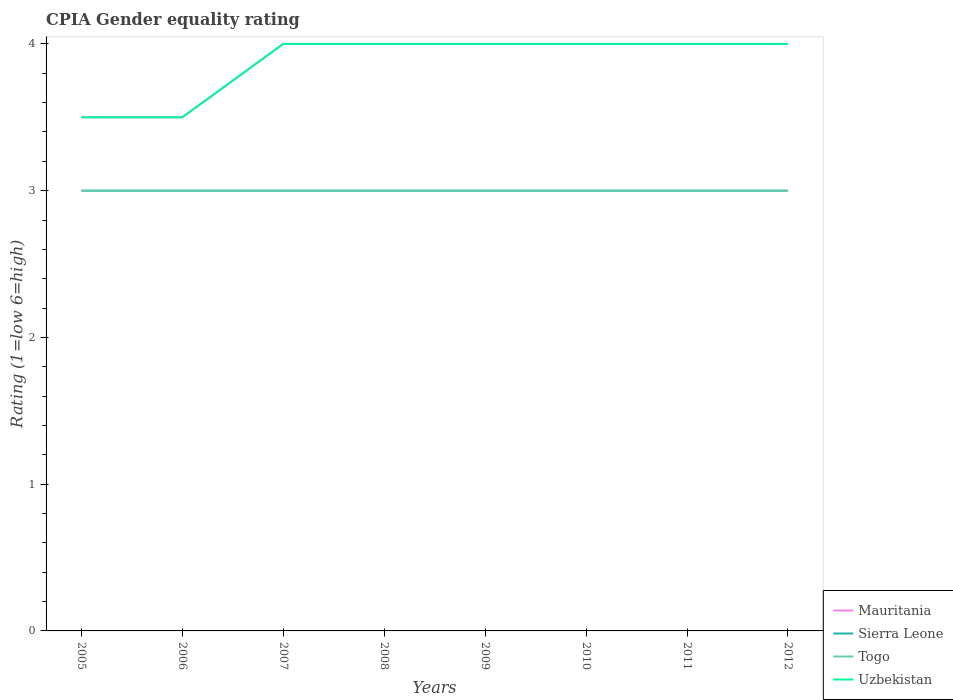How many different coloured lines are there?
Your response must be concise. 4. What is the total CPIA rating in Uzbekistan in the graph?
Provide a short and direct response. 0. How many years are there in the graph?
Offer a very short reply. 8. Are the values on the major ticks of Y-axis written in scientific E-notation?
Make the answer very short. No. Does the graph contain any zero values?
Your answer should be very brief. No. Does the graph contain grids?
Provide a short and direct response. No. Where does the legend appear in the graph?
Your answer should be very brief. Bottom right. How are the legend labels stacked?
Provide a short and direct response. Vertical. What is the title of the graph?
Ensure brevity in your answer.  CPIA Gender equality rating. Does "New Zealand" appear as one of the legend labels in the graph?
Your answer should be compact. No. What is the Rating (1=low 6=high) in Sierra Leone in 2006?
Provide a short and direct response. 3. What is the Rating (1=low 6=high) of Togo in 2006?
Keep it short and to the point. 3. What is the Rating (1=low 6=high) in Mauritania in 2007?
Your answer should be compact. 4. What is the Rating (1=low 6=high) in Sierra Leone in 2007?
Your answer should be compact. 3. What is the Rating (1=low 6=high) in Mauritania in 2008?
Make the answer very short. 4. What is the Rating (1=low 6=high) of Sierra Leone in 2008?
Make the answer very short. 3. What is the Rating (1=low 6=high) of Togo in 2008?
Your answer should be compact. 3. What is the Rating (1=low 6=high) in Mauritania in 2009?
Your answer should be compact. 4. What is the Rating (1=low 6=high) of Uzbekistan in 2009?
Keep it short and to the point. 4. What is the Rating (1=low 6=high) of Mauritania in 2010?
Give a very brief answer. 4. What is the Rating (1=low 6=high) of Sierra Leone in 2010?
Ensure brevity in your answer.  3. What is the Rating (1=low 6=high) of Uzbekistan in 2010?
Your answer should be very brief. 4. What is the Rating (1=low 6=high) of Mauritania in 2011?
Ensure brevity in your answer.  4. What is the Rating (1=low 6=high) in Togo in 2011?
Ensure brevity in your answer.  3. Across all years, what is the maximum Rating (1=low 6=high) of Mauritania?
Your answer should be compact. 4. Across all years, what is the maximum Rating (1=low 6=high) of Sierra Leone?
Provide a succinct answer. 3. Across all years, what is the maximum Rating (1=low 6=high) of Togo?
Make the answer very short. 3. Across all years, what is the maximum Rating (1=low 6=high) of Uzbekistan?
Provide a short and direct response. 4. Across all years, what is the minimum Rating (1=low 6=high) of Mauritania?
Provide a short and direct response. 3.5. Across all years, what is the minimum Rating (1=low 6=high) of Sierra Leone?
Provide a succinct answer. 3. Across all years, what is the minimum Rating (1=low 6=high) in Uzbekistan?
Offer a terse response. 3.5. What is the total Rating (1=low 6=high) of Mauritania in the graph?
Your response must be concise. 31. What is the difference between the Rating (1=low 6=high) in Mauritania in 2005 and that in 2006?
Your response must be concise. 0. What is the difference between the Rating (1=low 6=high) in Sierra Leone in 2005 and that in 2006?
Offer a terse response. 0. What is the difference between the Rating (1=low 6=high) of Uzbekistan in 2005 and that in 2006?
Offer a very short reply. 0. What is the difference between the Rating (1=low 6=high) of Sierra Leone in 2005 and that in 2007?
Provide a succinct answer. 0. What is the difference between the Rating (1=low 6=high) of Togo in 2005 and that in 2007?
Offer a very short reply. 0. What is the difference between the Rating (1=low 6=high) in Mauritania in 2005 and that in 2008?
Give a very brief answer. -0.5. What is the difference between the Rating (1=low 6=high) of Togo in 2005 and that in 2008?
Offer a very short reply. 0. What is the difference between the Rating (1=low 6=high) of Sierra Leone in 2005 and that in 2009?
Make the answer very short. 0. What is the difference between the Rating (1=low 6=high) in Sierra Leone in 2005 and that in 2010?
Provide a succinct answer. 0. What is the difference between the Rating (1=low 6=high) in Togo in 2005 and that in 2010?
Your response must be concise. 0. What is the difference between the Rating (1=low 6=high) in Sierra Leone in 2005 and that in 2011?
Give a very brief answer. 0. What is the difference between the Rating (1=low 6=high) of Togo in 2005 and that in 2011?
Provide a short and direct response. 0. What is the difference between the Rating (1=low 6=high) of Mauritania in 2005 and that in 2012?
Your response must be concise. -0.5. What is the difference between the Rating (1=low 6=high) in Sierra Leone in 2005 and that in 2012?
Give a very brief answer. 0. What is the difference between the Rating (1=low 6=high) in Uzbekistan in 2005 and that in 2012?
Your response must be concise. -0.5. What is the difference between the Rating (1=low 6=high) in Mauritania in 2006 and that in 2008?
Provide a short and direct response. -0.5. What is the difference between the Rating (1=low 6=high) of Togo in 2006 and that in 2008?
Offer a very short reply. 0. What is the difference between the Rating (1=low 6=high) of Uzbekistan in 2006 and that in 2008?
Your answer should be very brief. -0.5. What is the difference between the Rating (1=low 6=high) of Togo in 2006 and that in 2009?
Offer a terse response. 0. What is the difference between the Rating (1=low 6=high) in Togo in 2006 and that in 2010?
Offer a terse response. 0. What is the difference between the Rating (1=low 6=high) of Mauritania in 2006 and that in 2011?
Your answer should be very brief. -0.5. What is the difference between the Rating (1=low 6=high) in Sierra Leone in 2006 and that in 2011?
Offer a terse response. 0. What is the difference between the Rating (1=low 6=high) of Togo in 2006 and that in 2011?
Ensure brevity in your answer.  0. What is the difference between the Rating (1=low 6=high) of Uzbekistan in 2006 and that in 2011?
Your response must be concise. -0.5. What is the difference between the Rating (1=low 6=high) in Mauritania in 2006 and that in 2012?
Ensure brevity in your answer.  -0.5. What is the difference between the Rating (1=low 6=high) in Togo in 2006 and that in 2012?
Your answer should be compact. 0. What is the difference between the Rating (1=low 6=high) in Sierra Leone in 2007 and that in 2008?
Your response must be concise. 0. What is the difference between the Rating (1=low 6=high) of Mauritania in 2007 and that in 2009?
Make the answer very short. 0. What is the difference between the Rating (1=low 6=high) of Uzbekistan in 2007 and that in 2009?
Your response must be concise. 0. What is the difference between the Rating (1=low 6=high) of Sierra Leone in 2007 and that in 2010?
Your response must be concise. 0. What is the difference between the Rating (1=low 6=high) in Uzbekistan in 2007 and that in 2010?
Provide a succinct answer. 0. What is the difference between the Rating (1=low 6=high) in Sierra Leone in 2007 and that in 2011?
Provide a short and direct response. 0. What is the difference between the Rating (1=low 6=high) in Togo in 2007 and that in 2011?
Your answer should be compact. 0. What is the difference between the Rating (1=low 6=high) in Uzbekistan in 2007 and that in 2011?
Provide a succinct answer. 0. What is the difference between the Rating (1=low 6=high) of Sierra Leone in 2007 and that in 2012?
Offer a very short reply. 0. What is the difference between the Rating (1=low 6=high) in Togo in 2007 and that in 2012?
Your answer should be very brief. 0. What is the difference between the Rating (1=low 6=high) in Uzbekistan in 2007 and that in 2012?
Give a very brief answer. 0. What is the difference between the Rating (1=low 6=high) of Sierra Leone in 2008 and that in 2009?
Provide a short and direct response. 0. What is the difference between the Rating (1=low 6=high) in Uzbekistan in 2008 and that in 2009?
Provide a succinct answer. 0. What is the difference between the Rating (1=low 6=high) of Togo in 2008 and that in 2010?
Provide a succinct answer. 0. What is the difference between the Rating (1=low 6=high) of Uzbekistan in 2008 and that in 2010?
Provide a succinct answer. 0. What is the difference between the Rating (1=low 6=high) in Sierra Leone in 2008 and that in 2011?
Offer a terse response. 0. What is the difference between the Rating (1=low 6=high) in Mauritania in 2008 and that in 2012?
Your answer should be very brief. 0. What is the difference between the Rating (1=low 6=high) of Mauritania in 2009 and that in 2010?
Ensure brevity in your answer.  0. What is the difference between the Rating (1=low 6=high) of Uzbekistan in 2009 and that in 2010?
Provide a succinct answer. 0. What is the difference between the Rating (1=low 6=high) in Mauritania in 2009 and that in 2011?
Offer a very short reply. 0. What is the difference between the Rating (1=low 6=high) of Sierra Leone in 2010 and that in 2011?
Ensure brevity in your answer.  0. What is the difference between the Rating (1=low 6=high) in Togo in 2010 and that in 2012?
Your response must be concise. 0. What is the difference between the Rating (1=low 6=high) in Uzbekistan in 2010 and that in 2012?
Give a very brief answer. 0. What is the difference between the Rating (1=low 6=high) of Sierra Leone in 2011 and that in 2012?
Ensure brevity in your answer.  0. What is the difference between the Rating (1=low 6=high) in Sierra Leone in 2005 and the Rating (1=low 6=high) in Togo in 2006?
Your answer should be very brief. 0. What is the difference between the Rating (1=low 6=high) of Togo in 2005 and the Rating (1=low 6=high) of Uzbekistan in 2006?
Keep it short and to the point. -0.5. What is the difference between the Rating (1=low 6=high) in Mauritania in 2005 and the Rating (1=low 6=high) in Sierra Leone in 2007?
Ensure brevity in your answer.  0.5. What is the difference between the Rating (1=low 6=high) in Mauritania in 2005 and the Rating (1=low 6=high) in Togo in 2007?
Your answer should be compact. 0.5. What is the difference between the Rating (1=low 6=high) of Togo in 2005 and the Rating (1=low 6=high) of Uzbekistan in 2007?
Ensure brevity in your answer.  -1. What is the difference between the Rating (1=low 6=high) in Mauritania in 2005 and the Rating (1=low 6=high) in Uzbekistan in 2008?
Make the answer very short. -0.5. What is the difference between the Rating (1=low 6=high) of Sierra Leone in 2005 and the Rating (1=low 6=high) of Togo in 2008?
Your response must be concise. 0. What is the difference between the Rating (1=low 6=high) of Sierra Leone in 2005 and the Rating (1=low 6=high) of Uzbekistan in 2008?
Offer a very short reply. -1. What is the difference between the Rating (1=low 6=high) of Togo in 2005 and the Rating (1=low 6=high) of Uzbekistan in 2008?
Keep it short and to the point. -1. What is the difference between the Rating (1=low 6=high) of Mauritania in 2005 and the Rating (1=low 6=high) of Togo in 2009?
Your answer should be very brief. 0.5. What is the difference between the Rating (1=low 6=high) of Sierra Leone in 2005 and the Rating (1=low 6=high) of Uzbekistan in 2009?
Your answer should be very brief. -1. What is the difference between the Rating (1=low 6=high) in Mauritania in 2005 and the Rating (1=low 6=high) in Sierra Leone in 2010?
Offer a very short reply. 0.5. What is the difference between the Rating (1=low 6=high) of Mauritania in 2005 and the Rating (1=low 6=high) of Togo in 2010?
Your response must be concise. 0.5. What is the difference between the Rating (1=low 6=high) of Mauritania in 2005 and the Rating (1=low 6=high) of Uzbekistan in 2010?
Your response must be concise. -0.5. What is the difference between the Rating (1=low 6=high) in Sierra Leone in 2005 and the Rating (1=low 6=high) in Togo in 2010?
Offer a very short reply. 0. What is the difference between the Rating (1=low 6=high) of Sierra Leone in 2005 and the Rating (1=low 6=high) of Uzbekistan in 2010?
Your answer should be compact. -1. What is the difference between the Rating (1=low 6=high) in Togo in 2005 and the Rating (1=low 6=high) in Uzbekistan in 2010?
Make the answer very short. -1. What is the difference between the Rating (1=low 6=high) in Mauritania in 2005 and the Rating (1=low 6=high) in Sierra Leone in 2011?
Offer a very short reply. 0.5. What is the difference between the Rating (1=low 6=high) in Sierra Leone in 2005 and the Rating (1=low 6=high) in Togo in 2011?
Your answer should be very brief. 0. What is the difference between the Rating (1=low 6=high) in Mauritania in 2005 and the Rating (1=low 6=high) in Togo in 2012?
Provide a succinct answer. 0.5. What is the difference between the Rating (1=low 6=high) of Mauritania in 2005 and the Rating (1=low 6=high) of Uzbekistan in 2012?
Offer a terse response. -0.5. What is the difference between the Rating (1=low 6=high) in Sierra Leone in 2005 and the Rating (1=low 6=high) in Togo in 2012?
Provide a succinct answer. 0. What is the difference between the Rating (1=low 6=high) of Sierra Leone in 2005 and the Rating (1=low 6=high) of Uzbekistan in 2012?
Offer a terse response. -1. What is the difference between the Rating (1=low 6=high) of Sierra Leone in 2006 and the Rating (1=low 6=high) of Uzbekistan in 2007?
Your answer should be compact. -1. What is the difference between the Rating (1=low 6=high) of Mauritania in 2006 and the Rating (1=low 6=high) of Sierra Leone in 2008?
Your response must be concise. 0.5. What is the difference between the Rating (1=low 6=high) of Mauritania in 2006 and the Rating (1=low 6=high) of Togo in 2008?
Your answer should be very brief. 0.5. What is the difference between the Rating (1=low 6=high) in Sierra Leone in 2006 and the Rating (1=low 6=high) in Togo in 2008?
Your answer should be very brief. 0. What is the difference between the Rating (1=low 6=high) in Mauritania in 2006 and the Rating (1=low 6=high) in Uzbekistan in 2009?
Offer a terse response. -0.5. What is the difference between the Rating (1=low 6=high) of Sierra Leone in 2006 and the Rating (1=low 6=high) of Uzbekistan in 2009?
Keep it short and to the point. -1. What is the difference between the Rating (1=low 6=high) of Togo in 2006 and the Rating (1=low 6=high) of Uzbekistan in 2009?
Give a very brief answer. -1. What is the difference between the Rating (1=low 6=high) in Mauritania in 2006 and the Rating (1=low 6=high) in Sierra Leone in 2010?
Give a very brief answer. 0.5. What is the difference between the Rating (1=low 6=high) in Mauritania in 2006 and the Rating (1=low 6=high) in Uzbekistan in 2010?
Your response must be concise. -0.5. What is the difference between the Rating (1=low 6=high) in Sierra Leone in 2006 and the Rating (1=low 6=high) in Togo in 2010?
Give a very brief answer. 0. What is the difference between the Rating (1=low 6=high) of Mauritania in 2006 and the Rating (1=low 6=high) of Sierra Leone in 2011?
Ensure brevity in your answer.  0.5. What is the difference between the Rating (1=low 6=high) in Mauritania in 2006 and the Rating (1=low 6=high) in Uzbekistan in 2011?
Provide a short and direct response. -0.5. What is the difference between the Rating (1=low 6=high) in Sierra Leone in 2006 and the Rating (1=low 6=high) in Uzbekistan in 2011?
Your answer should be compact. -1. What is the difference between the Rating (1=low 6=high) of Mauritania in 2006 and the Rating (1=low 6=high) of Togo in 2012?
Keep it short and to the point. 0.5. What is the difference between the Rating (1=low 6=high) of Mauritania in 2007 and the Rating (1=low 6=high) of Uzbekistan in 2008?
Make the answer very short. 0. What is the difference between the Rating (1=low 6=high) in Sierra Leone in 2007 and the Rating (1=low 6=high) in Togo in 2008?
Provide a short and direct response. 0. What is the difference between the Rating (1=low 6=high) in Togo in 2007 and the Rating (1=low 6=high) in Uzbekistan in 2008?
Give a very brief answer. -1. What is the difference between the Rating (1=low 6=high) in Mauritania in 2007 and the Rating (1=low 6=high) in Uzbekistan in 2009?
Your answer should be very brief. 0. What is the difference between the Rating (1=low 6=high) of Mauritania in 2007 and the Rating (1=low 6=high) of Sierra Leone in 2010?
Offer a terse response. 1. What is the difference between the Rating (1=low 6=high) of Sierra Leone in 2007 and the Rating (1=low 6=high) of Uzbekistan in 2010?
Your answer should be very brief. -1. What is the difference between the Rating (1=low 6=high) of Togo in 2007 and the Rating (1=low 6=high) of Uzbekistan in 2010?
Give a very brief answer. -1. What is the difference between the Rating (1=low 6=high) of Mauritania in 2007 and the Rating (1=low 6=high) of Sierra Leone in 2011?
Provide a short and direct response. 1. What is the difference between the Rating (1=low 6=high) in Mauritania in 2007 and the Rating (1=low 6=high) in Togo in 2011?
Your answer should be compact. 1. What is the difference between the Rating (1=low 6=high) in Mauritania in 2007 and the Rating (1=low 6=high) in Sierra Leone in 2012?
Ensure brevity in your answer.  1. What is the difference between the Rating (1=low 6=high) in Mauritania in 2007 and the Rating (1=low 6=high) in Togo in 2012?
Ensure brevity in your answer.  1. What is the difference between the Rating (1=low 6=high) in Mauritania in 2007 and the Rating (1=low 6=high) in Uzbekistan in 2012?
Provide a succinct answer. 0. What is the difference between the Rating (1=low 6=high) in Sierra Leone in 2007 and the Rating (1=low 6=high) in Togo in 2012?
Your answer should be compact. 0. What is the difference between the Rating (1=low 6=high) in Sierra Leone in 2007 and the Rating (1=low 6=high) in Uzbekistan in 2012?
Provide a short and direct response. -1. What is the difference between the Rating (1=low 6=high) of Mauritania in 2008 and the Rating (1=low 6=high) of Sierra Leone in 2009?
Keep it short and to the point. 1. What is the difference between the Rating (1=low 6=high) of Mauritania in 2008 and the Rating (1=low 6=high) of Togo in 2009?
Offer a very short reply. 1. What is the difference between the Rating (1=low 6=high) in Sierra Leone in 2008 and the Rating (1=low 6=high) in Uzbekistan in 2009?
Offer a terse response. -1. What is the difference between the Rating (1=low 6=high) in Mauritania in 2008 and the Rating (1=low 6=high) in Uzbekistan in 2010?
Provide a short and direct response. 0. What is the difference between the Rating (1=low 6=high) in Sierra Leone in 2008 and the Rating (1=low 6=high) in Togo in 2010?
Your answer should be very brief. 0. What is the difference between the Rating (1=low 6=high) in Mauritania in 2008 and the Rating (1=low 6=high) in Sierra Leone in 2011?
Your answer should be very brief. 1. What is the difference between the Rating (1=low 6=high) in Mauritania in 2008 and the Rating (1=low 6=high) in Uzbekistan in 2011?
Provide a succinct answer. 0. What is the difference between the Rating (1=low 6=high) of Togo in 2008 and the Rating (1=low 6=high) of Uzbekistan in 2011?
Keep it short and to the point. -1. What is the difference between the Rating (1=low 6=high) of Sierra Leone in 2008 and the Rating (1=low 6=high) of Togo in 2012?
Your answer should be very brief. 0. What is the difference between the Rating (1=low 6=high) in Sierra Leone in 2008 and the Rating (1=low 6=high) in Uzbekistan in 2012?
Provide a short and direct response. -1. What is the difference between the Rating (1=low 6=high) of Togo in 2008 and the Rating (1=low 6=high) of Uzbekistan in 2012?
Your answer should be very brief. -1. What is the difference between the Rating (1=low 6=high) of Mauritania in 2009 and the Rating (1=low 6=high) of Togo in 2010?
Offer a very short reply. 1. What is the difference between the Rating (1=low 6=high) of Sierra Leone in 2009 and the Rating (1=low 6=high) of Togo in 2010?
Give a very brief answer. 0. What is the difference between the Rating (1=low 6=high) in Sierra Leone in 2009 and the Rating (1=low 6=high) in Uzbekistan in 2010?
Your answer should be very brief. -1. What is the difference between the Rating (1=low 6=high) of Mauritania in 2009 and the Rating (1=low 6=high) of Sierra Leone in 2011?
Offer a terse response. 1. What is the difference between the Rating (1=low 6=high) in Mauritania in 2009 and the Rating (1=low 6=high) in Togo in 2011?
Provide a short and direct response. 1. What is the difference between the Rating (1=low 6=high) in Mauritania in 2009 and the Rating (1=low 6=high) in Uzbekistan in 2011?
Make the answer very short. 0. What is the difference between the Rating (1=low 6=high) in Sierra Leone in 2009 and the Rating (1=low 6=high) in Uzbekistan in 2011?
Provide a short and direct response. -1. What is the difference between the Rating (1=low 6=high) of Mauritania in 2009 and the Rating (1=low 6=high) of Togo in 2012?
Provide a succinct answer. 1. What is the difference between the Rating (1=low 6=high) of Sierra Leone in 2009 and the Rating (1=low 6=high) of Togo in 2012?
Your response must be concise. 0. What is the difference between the Rating (1=low 6=high) of Sierra Leone in 2009 and the Rating (1=low 6=high) of Uzbekistan in 2012?
Offer a terse response. -1. What is the difference between the Rating (1=low 6=high) in Togo in 2009 and the Rating (1=low 6=high) in Uzbekistan in 2012?
Keep it short and to the point. -1. What is the difference between the Rating (1=low 6=high) of Mauritania in 2010 and the Rating (1=low 6=high) of Uzbekistan in 2011?
Provide a short and direct response. 0. What is the difference between the Rating (1=low 6=high) in Sierra Leone in 2010 and the Rating (1=low 6=high) in Uzbekistan in 2011?
Keep it short and to the point. -1. What is the difference between the Rating (1=low 6=high) of Mauritania in 2010 and the Rating (1=low 6=high) of Sierra Leone in 2012?
Provide a succinct answer. 1. What is the difference between the Rating (1=low 6=high) in Mauritania in 2010 and the Rating (1=low 6=high) in Uzbekistan in 2012?
Ensure brevity in your answer.  0. What is the difference between the Rating (1=low 6=high) of Sierra Leone in 2010 and the Rating (1=low 6=high) of Togo in 2012?
Offer a very short reply. 0. What is the difference between the Rating (1=low 6=high) of Sierra Leone in 2010 and the Rating (1=low 6=high) of Uzbekistan in 2012?
Provide a short and direct response. -1. What is the difference between the Rating (1=low 6=high) in Togo in 2010 and the Rating (1=low 6=high) in Uzbekistan in 2012?
Keep it short and to the point. -1. What is the difference between the Rating (1=low 6=high) in Mauritania in 2011 and the Rating (1=low 6=high) in Sierra Leone in 2012?
Ensure brevity in your answer.  1. What is the difference between the Rating (1=low 6=high) of Mauritania in 2011 and the Rating (1=low 6=high) of Togo in 2012?
Your answer should be very brief. 1. What is the difference between the Rating (1=low 6=high) of Mauritania in 2011 and the Rating (1=low 6=high) of Uzbekistan in 2012?
Offer a very short reply. 0. What is the difference between the Rating (1=low 6=high) of Sierra Leone in 2011 and the Rating (1=low 6=high) of Togo in 2012?
Your answer should be very brief. 0. What is the average Rating (1=low 6=high) of Mauritania per year?
Offer a terse response. 3.88. What is the average Rating (1=low 6=high) in Sierra Leone per year?
Ensure brevity in your answer.  3. What is the average Rating (1=low 6=high) of Togo per year?
Your response must be concise. 3. What is the average Rating (1=low 6=high) in Uzbekistan per year?
Keep it short and to the point. 3.88. In the year 2005, what is the difference between the Rating (1=low 6=high) in Sierra Leone and Rating (1=low 6=high) in Togo?
Keep it short and to the point. 0. In the year 2005, what is the difference between the Rating (1=low 6=high) of Sierra Leone and Rating (1=low 6=high) of Uzbekistan?
Provide a succinct answer. -0.5. In the year 2006, what is the difference between the Rating (1=low 6=high) in Mauritania and Rating (1=low 6=high) in Uzbekistan?
Ensure brevity in your answer.  0. In the year 2006, what is the difference between the Rating (1=low 6=high) of Togo and Rating (1=low 6=high) of Uzbekistan?
Your response must be concise. -0.5. In the year 2007, what is the difference between the Rating (1=low 6=high) of Mauritania and Rating (1=low 6=high) of Togo?
Your answer should be very brief. 1. In the year 2007, what is the difference between the Rating (1=low 6=high) of Togo and Rating (1=low 6=high) of Uzbekistan?
Ensure brevity in your answer.  -1. In the year 2008, what is the difference between the Rating (1=low 6=high) in Mauritania and Rating (1=low 6=high) in Sierra Leone?
Ensure brevity in your answer.  1. In the year 2008, what is the difference between the Rating (1=low 6=high) of Mauritania and Rating (1=low 6=high) of Togo?
Make the answer very short. 1. In the year 2008, what is the difference between the Rating (1=low 6=high) in Mauritania and Rating (1=low 6=high) in Uzbekistan?
Make the answer very short. 0. In the year 2008, what is the difference between the Rating (1=low 6=high) of Sierra Leone and Rating (1=low 6=high) of Togo?
Provide a short and direct response. 0. In the year 2008, what is the difference between the Rating (1=low 6=high) of Sierra Leone and Rating (1=low 6=high) of Uzbekistan?
Provide a succinct answer. -1. In the year 2008, what is the difference between the Rating (1=low 6=high) of Togo and Rating (1=low 6=high) of Uzbekistan?
Offer a very short reply. -1. In the year 2009, what is the difference between the Rating (1=low 6=high) of Mauritania and Rating (1=low 6=high) of Uzbekistan?
Keep it short and to the point. 0. In the year 2010, what is the difference between the Rating (1=low 6=high) in Mauritania and Rating (1=low 6=high) in Sierra Leone?
Keep it short and to the point. 1. In the year 2010, what is the difference between the Rating (1=low 6=high) in Mauritania and Rating (1=low 6=high) in Togo?
Make the answer very short. 1. In the year 2010, what is the difference between the Rating (1=low 6=high) in Sierra Leone and Rating (1=low 6=high) in Uzbekistan?
Your response must be concise. -1. In the year 2011, what is the difference between the Rating (1=low 6=high) in Mauritania and Rating (1=low 6=high) in Sierra Leone?
Ensure brevity in your answer.  1. In the year 2011, what is the difference between the Rating (1=low 6=high) in Sierra Leone and Rating (1=low 6=high) in Togo?
Give a very brief answer. 0. In the year 2011, what is the difference between the Rating (1=low 6=high) of Sierra Leone and Rating (1=low 6=high) of Uzbekistan?
Provide a short and direct response. -1. In the year 2011, what is the difference between the Rating (1=low 6=high) in Togo and Rating (1=low 6=high) in Uzbekistan?
Ensure brevity in your answer.  -1. In the year 2012, what is the difference between the Rating (1=low 6=high) in Mauritania and Rating (1=low 6=high) in Togo?
Give a very brief answer. 1. In the year 2012, what is the difference between the Rating (1=low 6=high) of Mauritania and Rating (1=low 6=high) of Uzbekistan?
Your answer should be very brief. 0. In the year 2012, what is the difference between the Rating (1=low 6=high) in Sierra Leone and Rating (1=low 6=high) in Uzbekistan?
Provide a succinct answer. -1. In the year 2012, what is the difference between the Rating (1=low 6=high) of Togo and Rating (1=low 6=high) of Uzbekistan?
Ensure brevity in your answer.  -1. What is the ratio of the Rating (1=low 6=high) in Uzbekistan in 2005 to that in 2006?
Provide a short and direct response. 1. What is the ratio of the Rating (1=low 6=high) of Mauritania in 2005 to that in 2007?
Give a very brief answer. 0.88. What is the ratio of the Rating (1=low 6=high) in Mauritania in 2005 to that in 2008?
Provide a short and direct response. 0.88. What is the ratio of the Rating (1=low 6=high) of Mauritania in 2005 to that in 2009?
Keep it short and to the point. 0.88. What is the ratio of the Rating (1=low 6=high) of Uzbekistan in 2005 to that in 2009?
Your answer should be very brief. 0.88. What is the ratio of the Rating (1=low 6=high) of Mauritania in 2005 to that in 2010?
Your answer should be very brief. 0.88. What is the ratio of the Rating (1=low 6=high) of Sierra Leone in 2005 to that in 2010?
Your response must be concise. 1. What is the ratio of the Rating (1=low 6=high) of Uzbekistan in 2005 to that in 2010?
Make the answer very short. 0.88. What is the ratio of the Rating (1=low 6=high) in Mauritania in 2005 to that in 2011?
Make the answer very short. 0.88. What is the ratio of the Rating (1=low 6=high) of Uzbekistan in 2005 to that in 2011?
Your response must be concise. 0.88. What is the ratio of the Rating (1=low 6=high) in Mauritania in 2005 to that in 2012?
Offer a terse response. 0.88. What is the ratio of the Rating (1=low 6=high) in Sierra Leone in 2005 to that in 2012?
Provide a short and direct response. 1. What is the ratio of the Rating (1=low 6=high) of Uzbekistan in 2005 to that in 2012?
Provide a short and direct response. 0.88. What is the ratio of the Rating (1=low 6=high) in Sierra Leone in 2006 to that in 2007?
Your answer should be very brief. 1. What is the ratio of the Rating (1=low 6=high) of Togo in 2006 to that in 2008?
Provide a short and direct response. 1. What is the ratio of the Rating (1=low 6=high) in Mauritania in 2006 to that in 2009?
Ensure brevity in your answer.  0.88. What is the ratio of the Rating (1=low 6=high) in Uzbekistan in 2006 to that in 2009?
Provide a short and direct response. 0.88. What is the ratio of the Rating (1=low 6=high) in Sierra Leone in 2006 to that in 2010?
Ensure brevity in your answer.  1. What is the ratio of the Rating (1=low 6=high) of Mauritania in 2006 to that in 2011?
Your response must be concise. 0.88. What is the ratio of the Rating (1=low 6=high) in Sierra Leone in 2006 to that in 2011?
Make the answer very short. 1. What is the ratio of the Rating (1=low 6=high) in Mauritania in 2007 to that in 2008?
Provide a succinct answer. 1. What is the ratio of the Rating (1=low 6=high) in Sierra Leone in 2007 to that in 2008?
Ensure brevity in your answer.  1. What is the ratio of the Rating (1=low 6=high) of Uzbekistan in 2007 to that in 2008?
Give a very brief answer. 1. What is the ratio of the Rating (1=low 6=high) of Mauritania in 2007 to that in 2009?
Your response must be concise. 1. What is the ratio of the Rating (1=low 6=high) in Togo in 2007 to that in 2009?
Your answer should be very brief. 1. What is the ratio of the Rating (1=low 6=high) of Uzbekistan in 2007 to that in 2009?
Your answer should be very brief. 1. What is the ratio of the Rating (1=low 6=high) of Sierra Leone in 2007 to that in 2010?
Provide a short and direct response. 1. What is the ratio of the Rating (1=low 6=high) of Togo in 2007 to that in 2010?
Provide a succinct answer. 1. What is the ratio of the Rating (1=low 6=high) in Uzbekistan in 2007 to that in 2011?
Give a very brief answer. 1. What is the ratio of the Rating (1=low 6=high) of Togo in 2007 to that in 2012?
Ensure brevity in your answer.  1. What is the ratio of the Rating (1=low 6=high) in Uzbekistan in 2007 to that in 2012?
Provide a short and direct response. 1. What is the ratio of the Rating (1=low 6=high) of Sierra Leone in 2008 to that in 2009?
Your answer should be compact. 1. What is the ratio of the Rating (1=low 6=high) of Togo in 2008 to that in 2009?
Offer a very short reply. 1. What is the ratio of the Rating (1=low 6=high) of Togo in 2008 to that in 2010?
Provide a short and direct response. 1. What is the ratio of the Rating (1=low 6=high) in Togo in 2008 to that in 2011?
Make the answer very short. 1. What is the ratio of the Rating (1=low 6=high) in Sierra Leone in 2008 to that in 2012?
Offer a very short reply. 1. What is the ratio of the Rating (1=low 6=high) of Togo in 2008 to that in 2012?
Provide a succinct answer. 1. What is the ratio of the Rating (1=low 6=high) of Uzbekistan in 2008 to that in 2012?
Your response must be concise. 1. What is the ratio of the Rating (1=low 6=high) of Mauritania in 2009 to that in 2010?
Keep it short and to the point. 1. What is the ratio of the Rating (1=low 6=high) of Sierra Leone in 2009 to that in 2010?
Your answer should be very brief. 1. What is the ratio of the Rating (1=low 6=high) in Togo in 2009 to that in 2010?
Offer a terse response. 1. What is the ratio of the Rating (1=low 6=high) in Mauritania in 2009 to that in 2011?
Provide a short and direct response. 1. What is the ratio of the Rating (1=low 6=high) of Sierra Leone in 2009 to that in 2011?
Provide a succinct answer. 1. What is the ratio of the Rating (1=low 6=high) in Mauritania in 2009 to that in 2012?
Keep it short and to the point. 1. What is the ratio of the Rating (1=low 6=high) of Sierra Leone in 2009 to that in 2012?
Your answer should be very brief. 1. What is the ratio of the Rating (1=low 6=high) in Togo in 2009 to that in 2012?
Offer a very short reply. 1. What is the ratio of the Rating (1=low 6=high) in Uzbekistan in 2009 to that in 2012?
Keep it short and to the point. 1. What is the ratio of the Rating (1=low 6=high) of Uzbekistan in 2010 to that in 2011?
Offer a terse response. 1. What is the ratio of the Rating (1=low 6=high) in Mauritania in 2010 to that in 2012?
Your answer should be very brief. 1. What is the ratio of the Rating (1=low 6=high) of Togo in 2011 to that in 2012?
Your response must be concise. 1. What is the ratio of the Rating (1=low 6=high) in Uzbekistan in 2011 to that in 2012?
Provide a short and direct response. 1. What is the difference between the highest and the second highest Rating (1=low 6=high) in Mauritania?
Make the answer very short. 0. What is the difference between the highest and the second highest Rating (1=low 6=high) in Sierra Leone?
Offer a terse response. 0. What is the difference between the highest and the second highest Rating (1=low 6=high) of Togo?
Offer a terse response. 0. What is the difference between the highest and the lowest Rating (1=low 6=high) of Mauritania?
Keep it short and to the point. 0.5. What is the difference between the highest and the lowest Rating (1=low 6=high) in Sierra Leone?
Make the answer very short. 0. What is the difference between the highest and the lowest Rating (1=low 6=high) of Togo?
Your answer should be very brief. 0. 